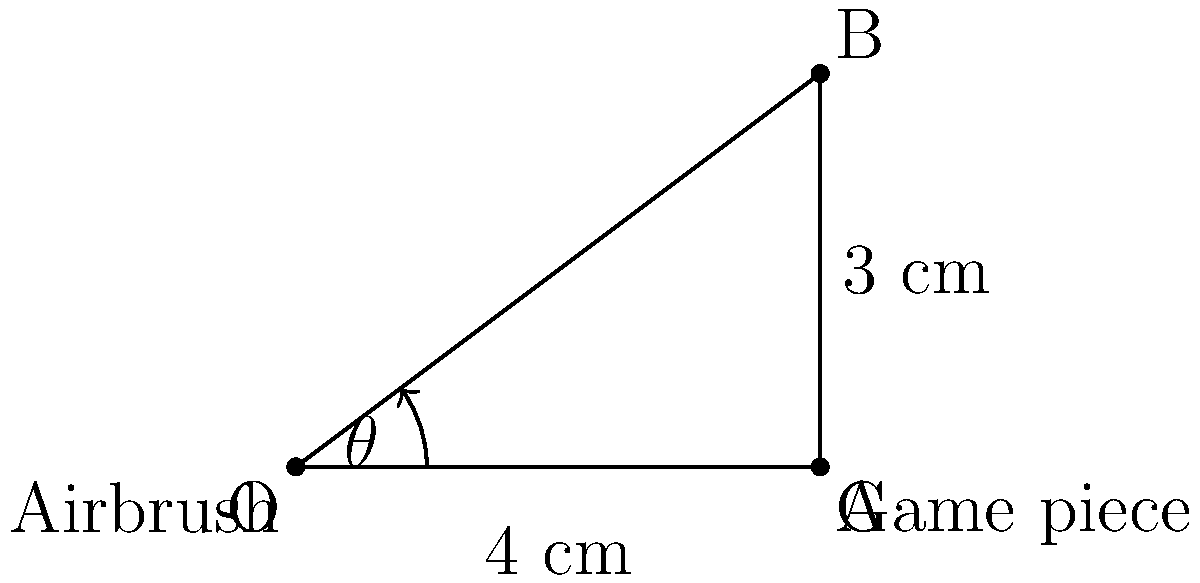You're airbrushing a small detail on a game piece that's 3 cm tall and 4 cm away from your airbrush nozzle. What's the optimal angle $\theta$ (in degrees) between the airbrush and the horizontal surface to aim at the top of the game piece for the best coverage? To find the optimal angle $\theta$, we need to use trigonometry:

1) The situation forms a right-angled triangle, with:
   - The adjacent side (horizontal distance) = 4 cm
   - The opposite side (height of game piece) = 3 cm
   - The hypotenuse is the line from the airbrush to the top of the game piece

2) We can use the tangent function to find the angle:

   $\tan(\theta) = \frac{\text{opposite}}{\text{adjacent}} = \frac{3}{4}$

3) To find $\theta$, we need to use the inverse tangent (arctan or $\tan^{-1}$):

   $\theta = \tan^{-1}(\frac{3}{4})$

4) Using a calculator or trigonometric tables:

   $\theta \approx 36.87°$

5) Rounding to the nearest degree:

   $\theta \approx 37°$

This angle will provide the most direct aim at the top of the game piece, ensuring optimal coverage for the small details.
Answer: 37° 